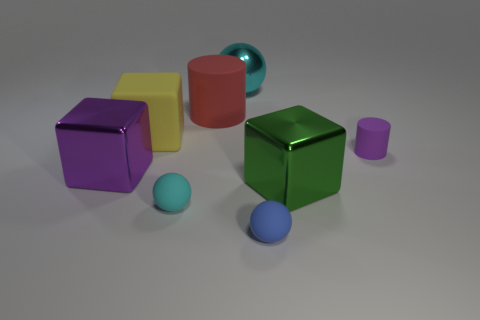Add 2 small blue matte objects. How many objects exist? 10 Subtract all tiny blue rubber spheres. How many spheres are left? 2 Subtract all cylinders. How many objects are left? 6 Subtract 1 cylinders. How many cylinders are left? 1 Subtract all green spheres. Subtract all yellow cylinders. How many spheres are left? 3 Subtract all purple spheres. How many cyan cubes are left? 0 Subtract all spheres. Subtract all large blue rubber blocks. How many objects are left? 5 Add 8 blue things. How many blue things are left? 9 Add 6 big yellow matte cylinders. How many big yellow matte cylinders exist? 6 Subtract all purple cylinders. How many cylinders are left? 1 